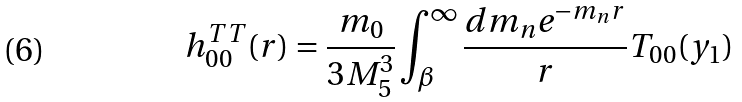<formula> <loc_0><loc_0><loc_500><loc_500>h _ { 0 0 } ^ { T T } ( r ) = \frac { m _ { 0 } } { 3 M _ { 5 } ^ { 3 } } \int _ { \beta } ^ { \infty } \frac { d m _ { n } e ^ { - m _ { n } r } } { r } T _ { 0 0 } ( y _ { 1 } )</formula> 